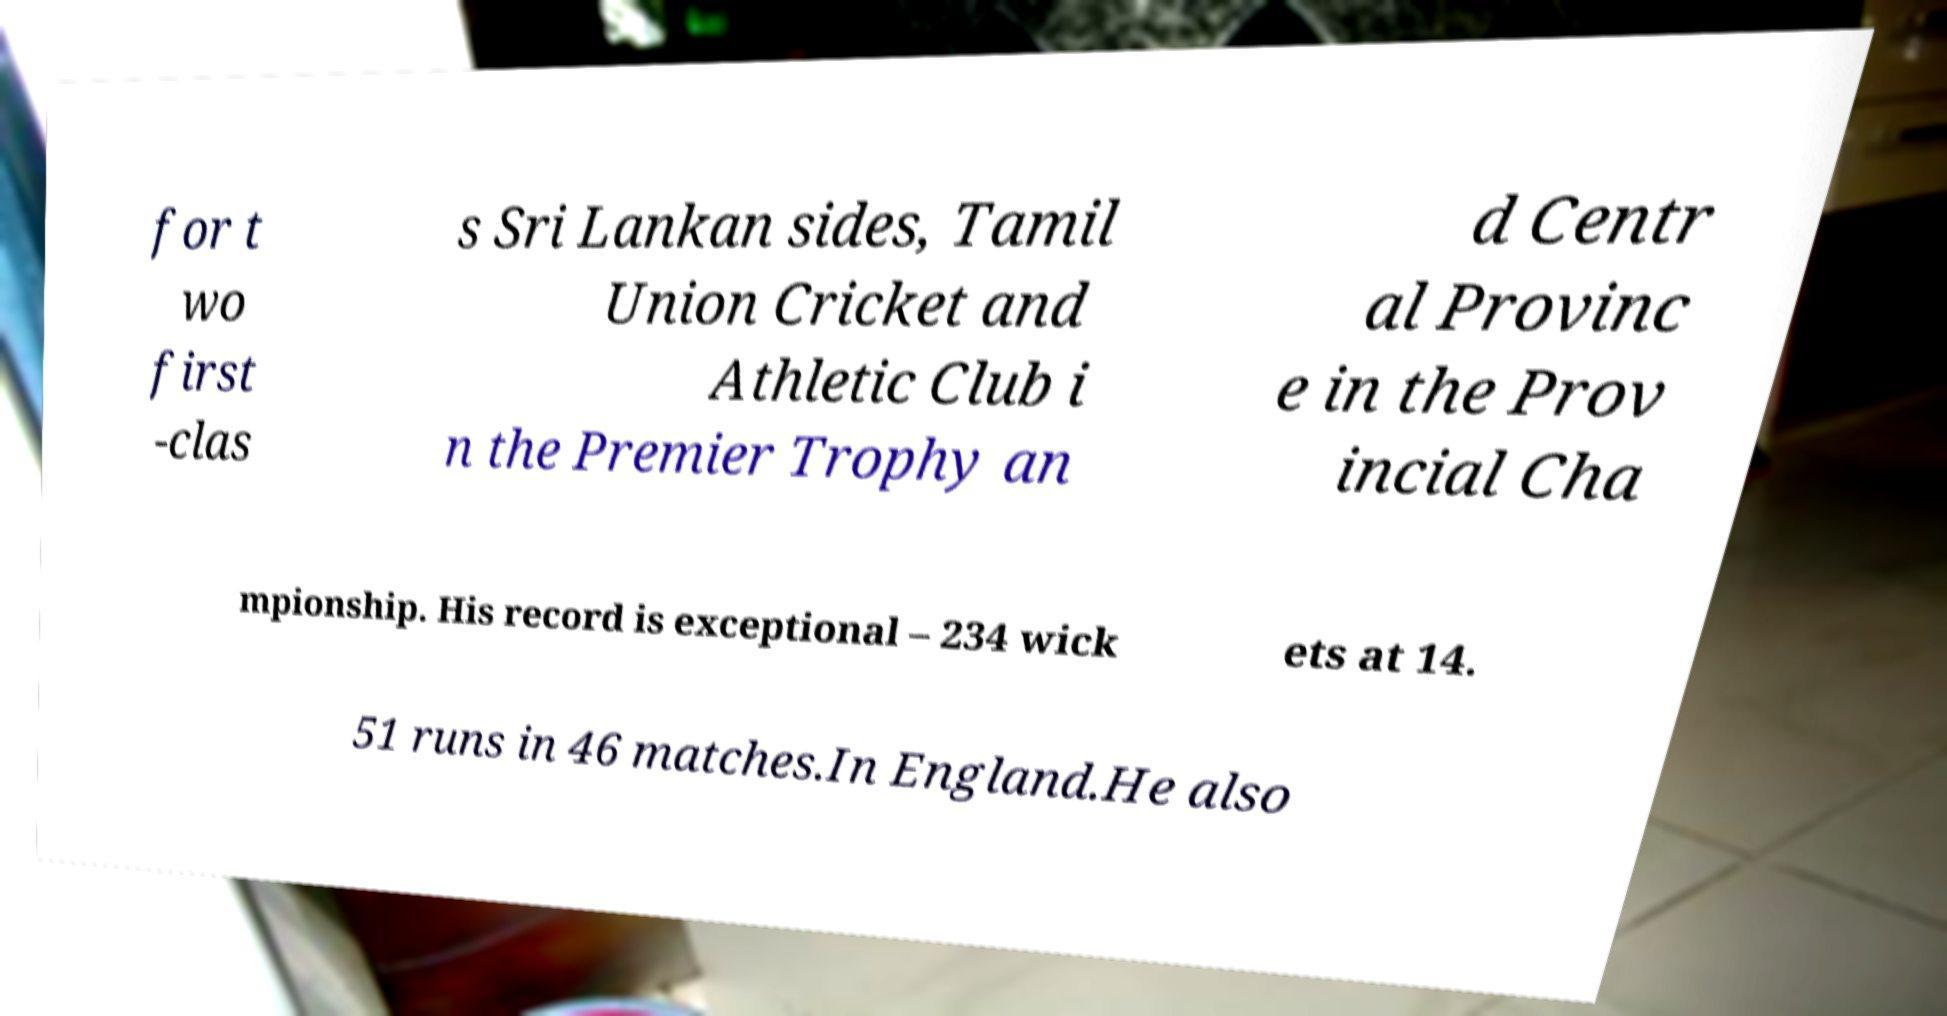Please read and relay the text visible in this image. What does it say? for t wo first -clas s Sri Lankan sides, Tamil Union Cricket and Athletic Club i n the Premier Trophy an d Centr al Provinc e in the Prov incial Cha mpionship. His record is exceptional – 234 wick ets at 14. 51 runs in 46 matches.In England.He also 